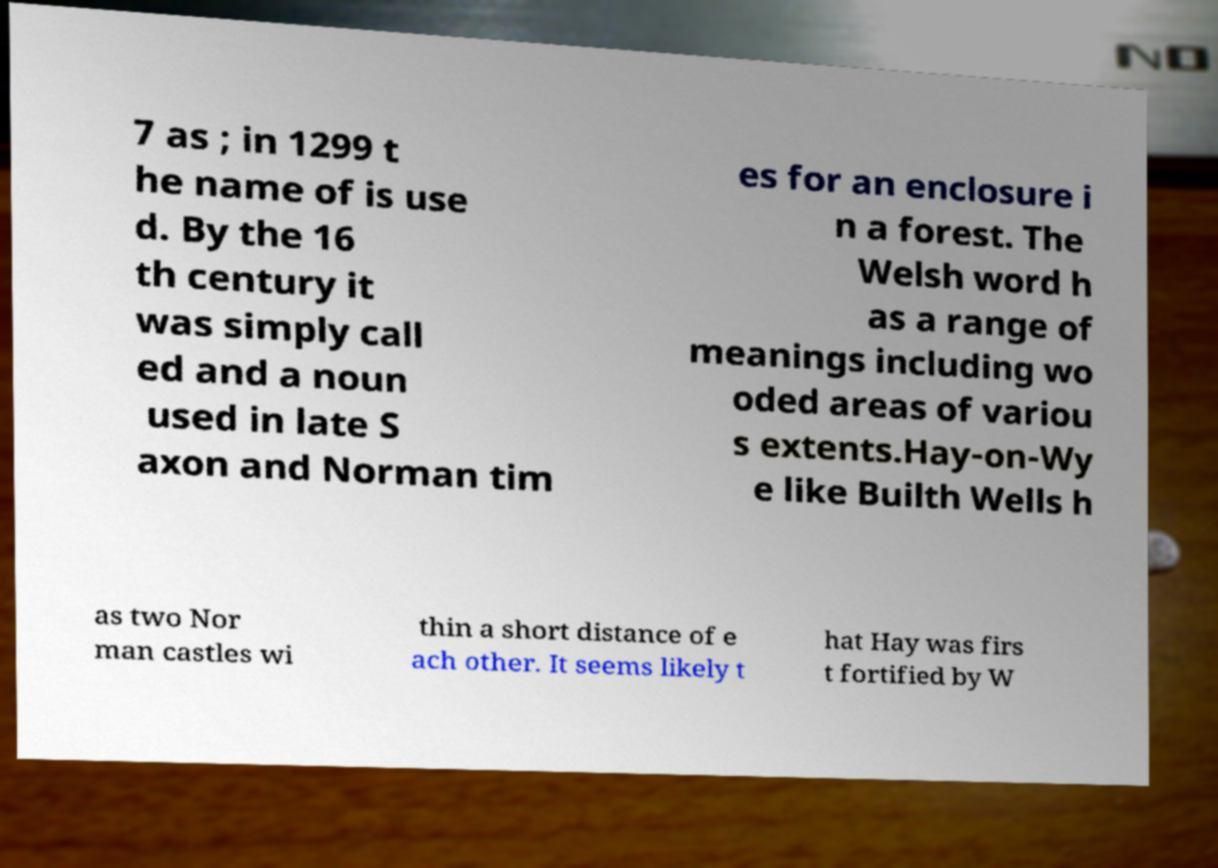Please identify and transcribe the text found in this image. 7 as ; in 1299 t he name of is use d. By the 16 th century it was simply call ed and a noun used in late S axon and Norman tim es for an enclosure i n a forest. The Welsh word h as a range of meanings including wo oded areas of variou s extents.Hay-on-Wy e like Builth Wells h as two Nor man castles wi thin a short distance of e ach other. It seems likely t hat Hay was firs t fortified by W 